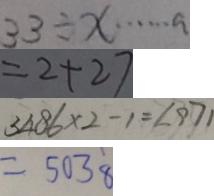<formula> <loc_0><loc_0><loc_500><loc_500>3 3 \div x \cdots a 
 = 2 + 2 7 
 3 4 8 6 \times 2 - 1 = 6 9 7 1 
 = 5 0 3 8</formula> 